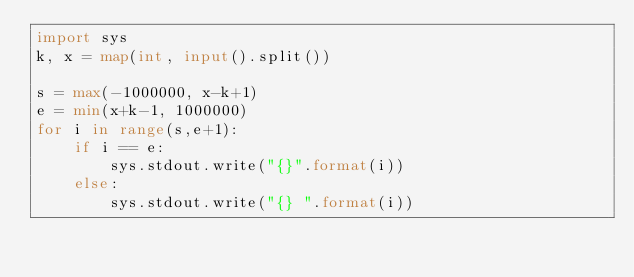<code> <loc_0><loc_0><loc_500><loc_500><_Python_>import sys
k, x = map(int, input().split())

s = max(-1000000, x-k+1)
e = min(x+k-1, 1000000)
for i in range(s,e+1):
    if i == e:
        sys.stdout.write("{}".format(i))
    else:
        sys.stdout.write("{} ".format(i))</code> 